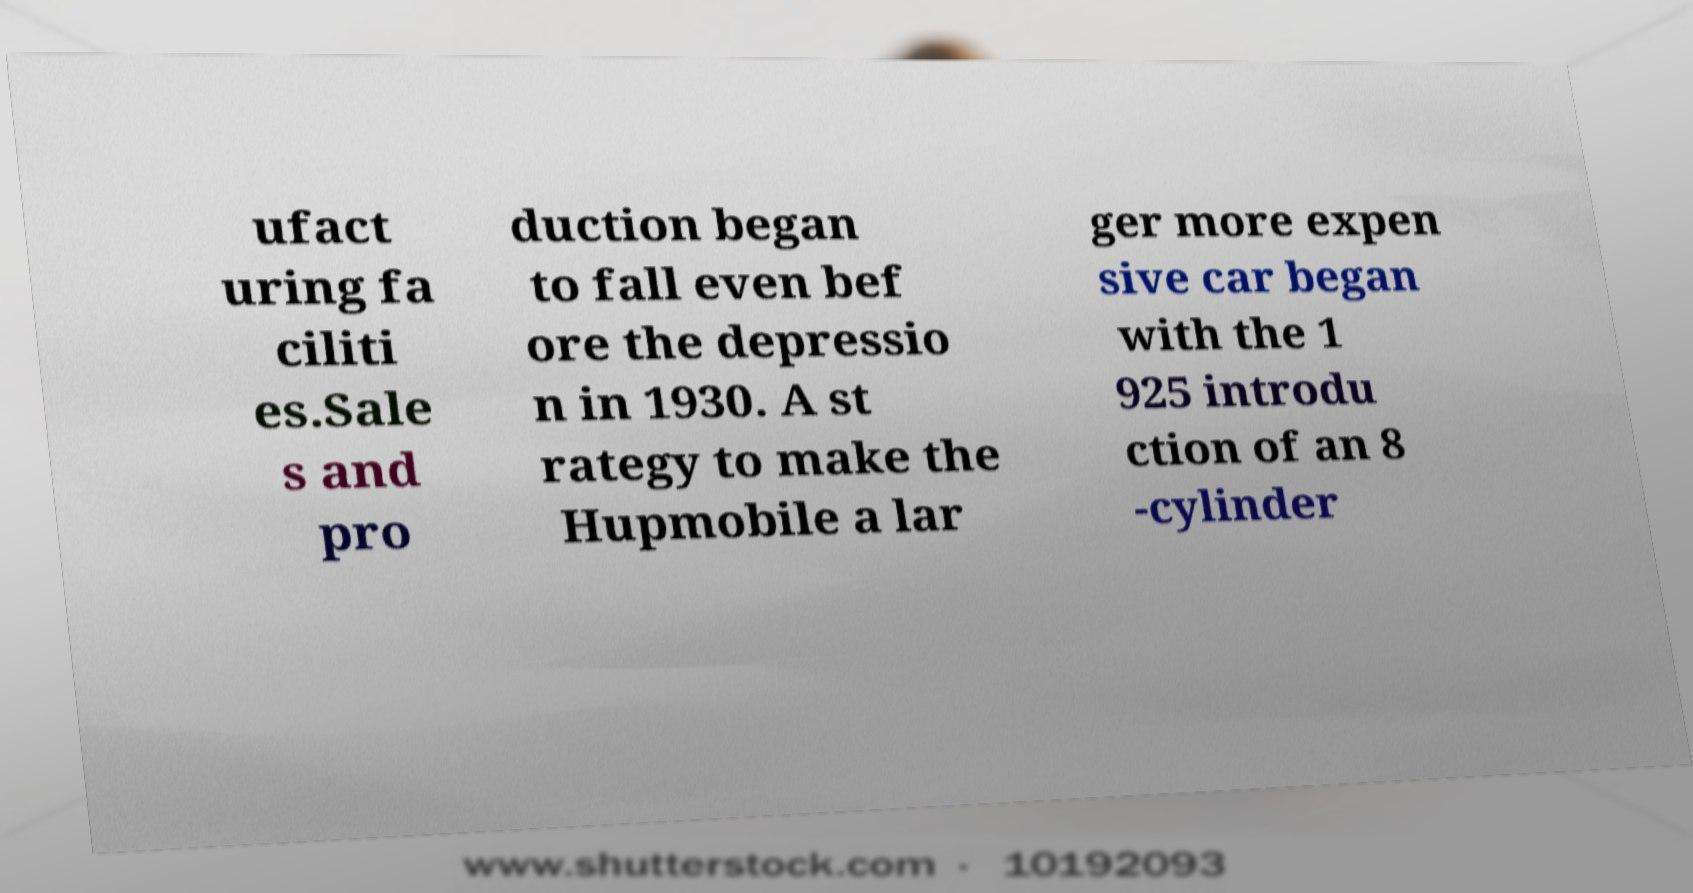Could you assist in decoding the text presented in this image and type it out clearly? ufact uring fa ciliti es.Sale s and pro duction began to fall even bef ore the depressio n in 1930. A st rategy to make the Hupmobile a lar ger more expen sive car began with the 1 925 introdu ction of an 8 -cylinder 